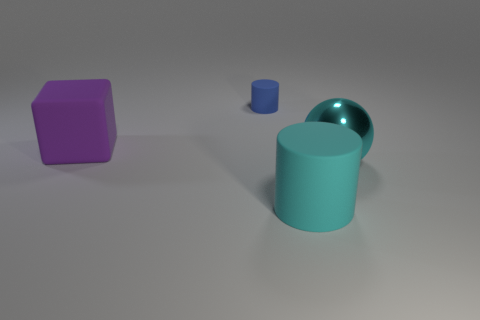Is there anything else that has the same material as the sphere?
Provide a succinct answer. No. Is there anything else that is the same shape as the large purple rubber thing?
Your answer should be compact. No. Are the cyan thing left of the metal sphere and the object that is right of the big cyan rubber cylinder made of the same material?
Make the answer very short. No. How many big cylinders have the same color as the large shiny object?
Provide a short and direct response. 1. What is the shape of the thing that is on the left side of the large rubber cylinder and in front of the tiny blue cylinder?
Offer a very short reply. Cube. What is the color of the rubber thing that is both left of the cyan rubber cylinder and in front of the tiny blue rubber cylinder?
Your answer should be very brief. Purple. Is the number of matte cylinders in front of the large purple block greater than the number of big metallic objects that are in front of the big cyan ball?
Make the answer very short. Yes. The large rubber object on the left side of the big cyan rubber object is what color?
Ensure brevity in your answer.  Purple. There is a large rubber object in front of the purple thing; is its shape the same as the tiny rubber object that is right of the purple object?
Give a very brief answer. Yes. Is there a rubber cube of the same size as the cyan matte object?
Make the answer very short. Yes. 